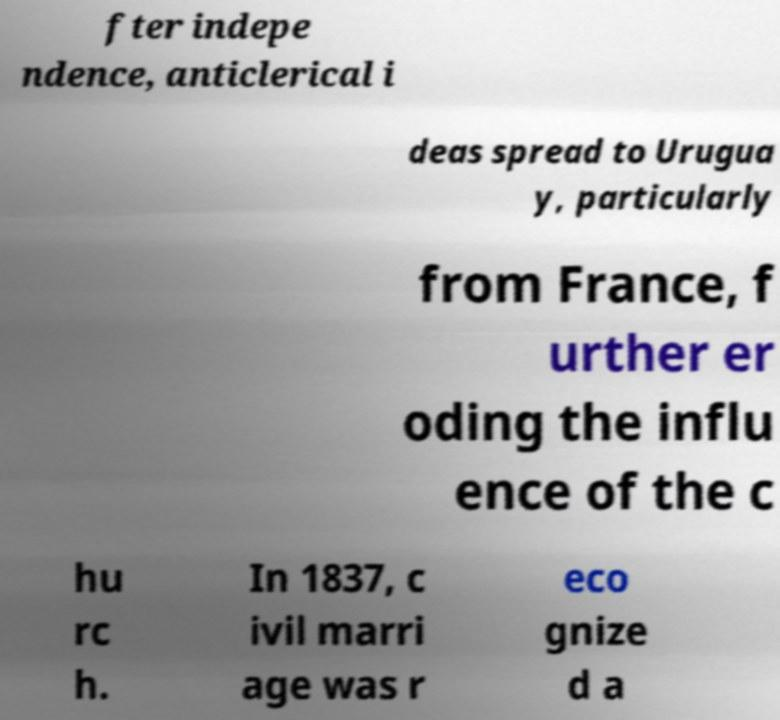For documentation purposes, I need the text within this image transcribed. Could you provide that? fter indepe ndence, anticlerical i deas spread to Urugua y, particularly from France, f urther er oding the influ ence of the c hu rc h. In 1837, c ivil marri age was r eco gnize d a 